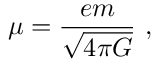Convert formula to latex. <formula><loc_0><loc_0><loc_500><loc_500>\mu = \frac { e m } { \sqrt { 4 \pi G } } \ ,</formula> 